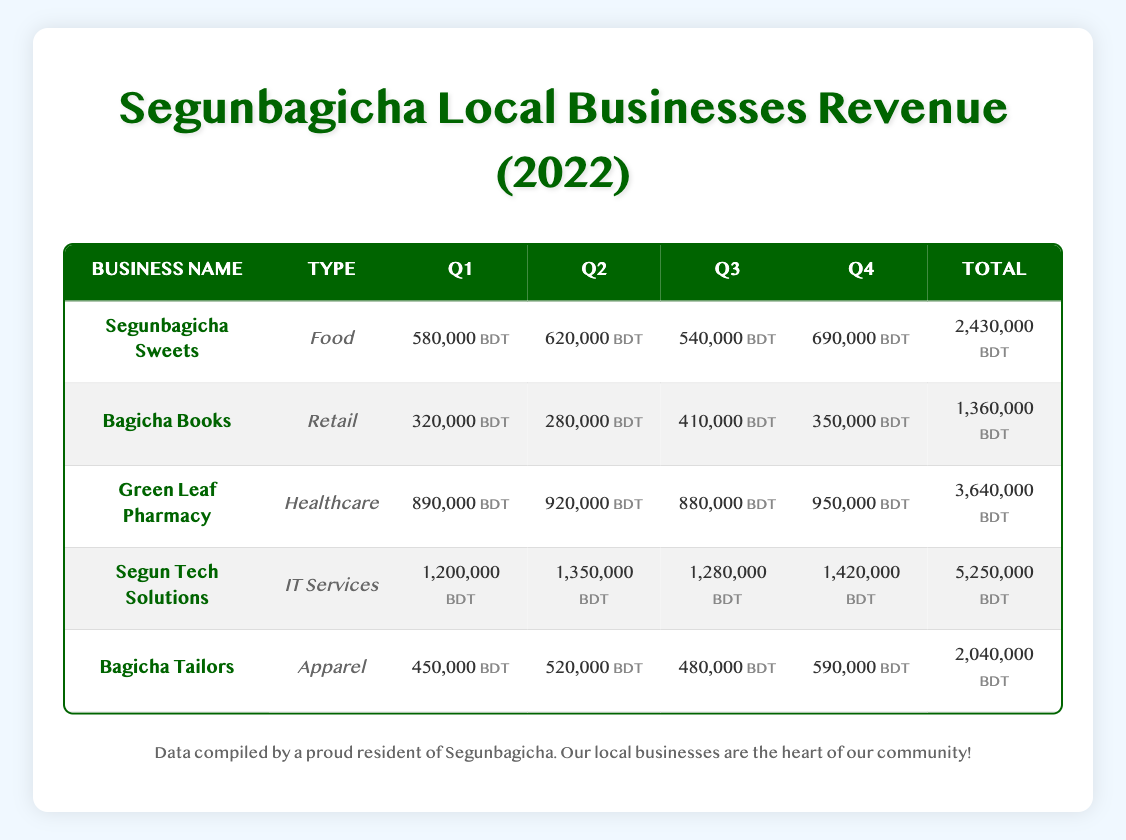What is the total revenue of Green Leaf Pharmacy for Q3? The table lists Green Leaf Pharmacy's revenue for Q3 as 880,000 BDT.
Answer: 880,000 BDT Which business had the highest revenue in Q2? In Q2, Segun Tech Solutions had the highest revenue of 1,350,000 BDT compared to other businesses.
Answer: Segun Tech Solutions What is the total revenue generated by Segunbagicha Sweets in 2022? To find the total, add the quarterly revenues: 580,000 + 620,000 + 540,000 + 690,000 = 2,430,000 BDT.
Answer: 2,430,000 BDT Did Bagicha Books earn more than 1 million BDT in total revenue for the year? The total revenue for Bagicha Books is 1,360,000 BDT, which is more than 1 million.
Answer: Yes What was the average quarterly revenue for Segun Tech Solutions? The total revenue is 5,250,000 BDT from four quarters, so the average is 5,250,000 / 4 = 1,312,500 BDT.
Answer: 1,312,500 BDT How much more did Green Leaf Pharmacy earn in Q4 compared to Q1? Green Leaf Pharmacy earned 950,000 BDT in Q4 and 890,000 BDT in Q1. The difference is 950,000 - 890,000 = 60,000 BDT.
Answer: 60,000 BDT Is the revenue of Bagicha Tailors in Q3 less than 500,000 BDT? Bagicha Tailors earned 480,000 BDT in Q3, which is less than 500,000 BDT.
Answer: Yes Which business showed the least revenue growth from Q1 to Q4? Analyzing the quarterly growth: Segunbagicha Sweets (110,000), Bagicha Books (30,000), Green Leaf Pharmacy (60,000), Segun Tech Solutions (220,000), Bagicha Tailors (140,000). Bagicha Books showed the least growth of 30,000 BDT.
Answer: Bagicha Books By how much did the total revenue of all businesses exceed 10 million BDT in 2022? The total revenues are: 2,430,000 + 1,360,000 + 3,640,000 + 5,250,000 + 2,040,000 = 14,720,000 BDT. Since this is greater than 10 million BDT, the excess is 14,720,000 - 10,000,000 = 4,720,000 BDT.
Answer: 4,720,000 BDT 